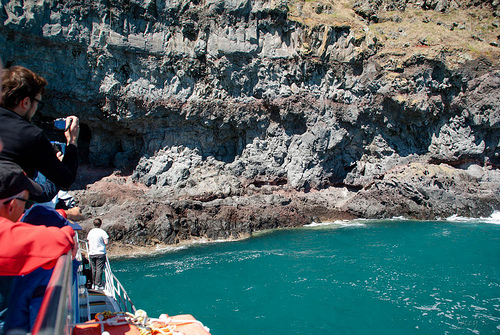<image>
Is there a person on the water? Yes. Looking at the image, I can see the person is positioned on top of the water, with the water providing support. 